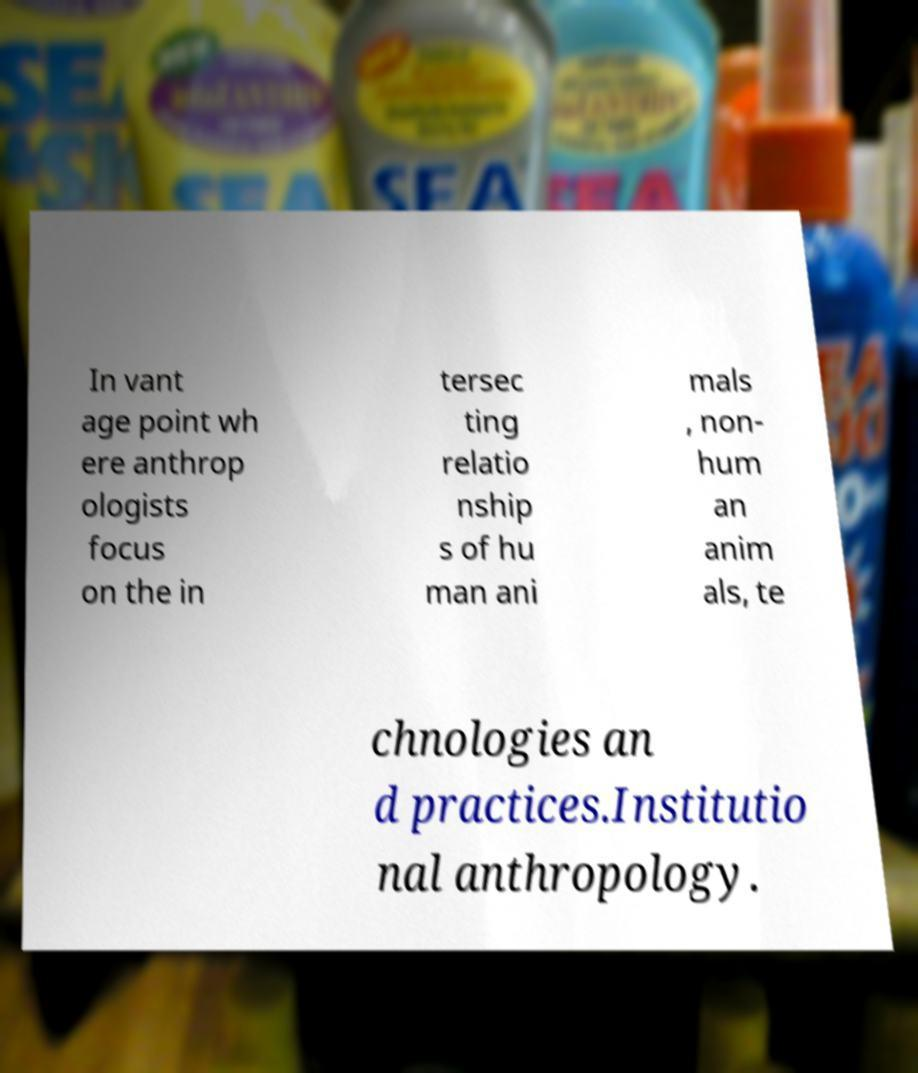What messages or text are displayed in this image? I need them in a readable, typed format. In vant age point wh ere anthrop ologists focus on the in tersec ting relatio nship s of hu man ani mals , non- hum an anim als, te chnologies an d practices.Institutio nal anthropology. 